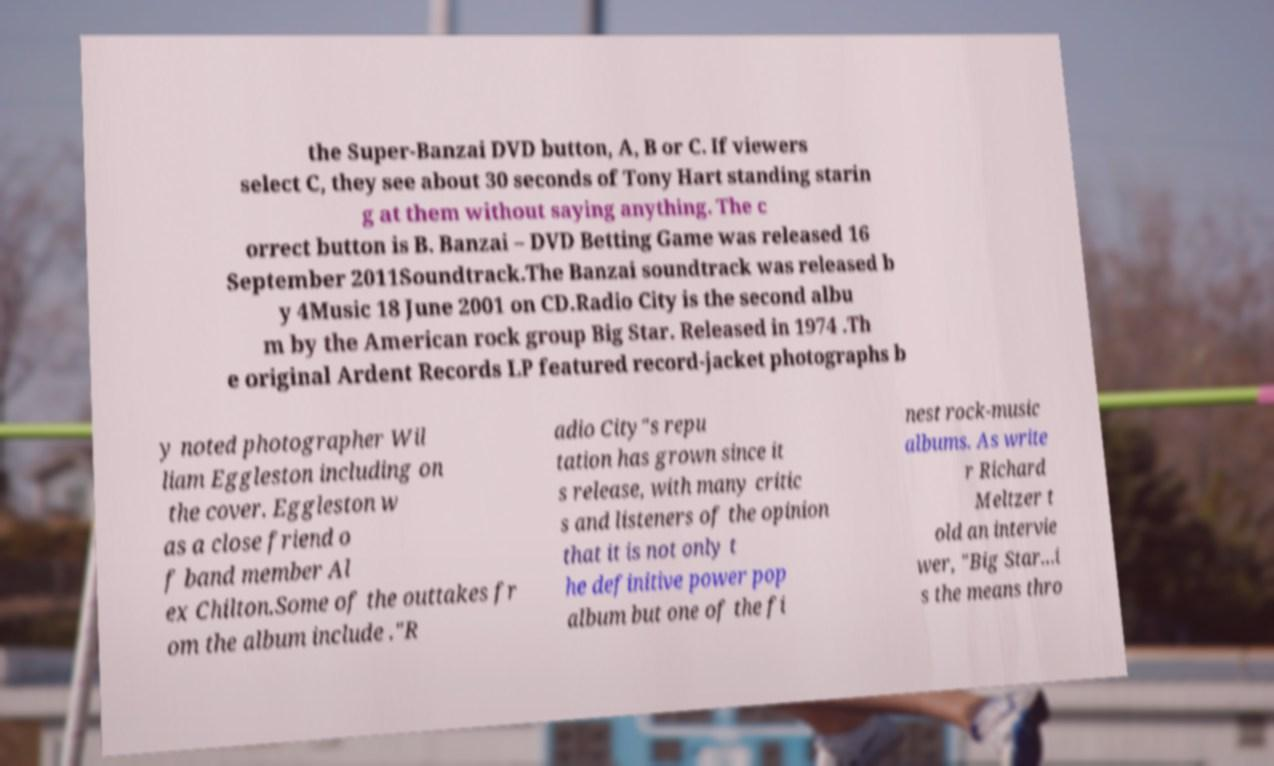There's text embedded in this image that I need extracted. Can you transcribe it verbatim? the Super-Banzai DVD button, A, B or C. If viewers select C, they see about 30 seconds of Tony Hart standing starin g at them without saying anything. The c orrect button is B. Banzai – DVD Betting Game was released 16 September 2011Soundtrack.The Banzai soundtrack was released b y 4Music 18 June 2001 on CD.Radio City is the second albu m by the American rock group Big Star. Released in 1974 .Th e original Ardent Records LP featured record-jacket photographs b y noted photographer Wil liam Eggleston including on the cover. Eggleston w as a close friend o f band member Al ex Chilton.Some of the outtakes fr om the album include ."R adio City"s repu tation has grown since it s release, with many critic s and listeners of the opinion that it is not only t he definitive power pop album but one of the fi nest rock-music albums. As write r Richard Meltzer t old an intervie wer, "Big Star...i s the means thro 